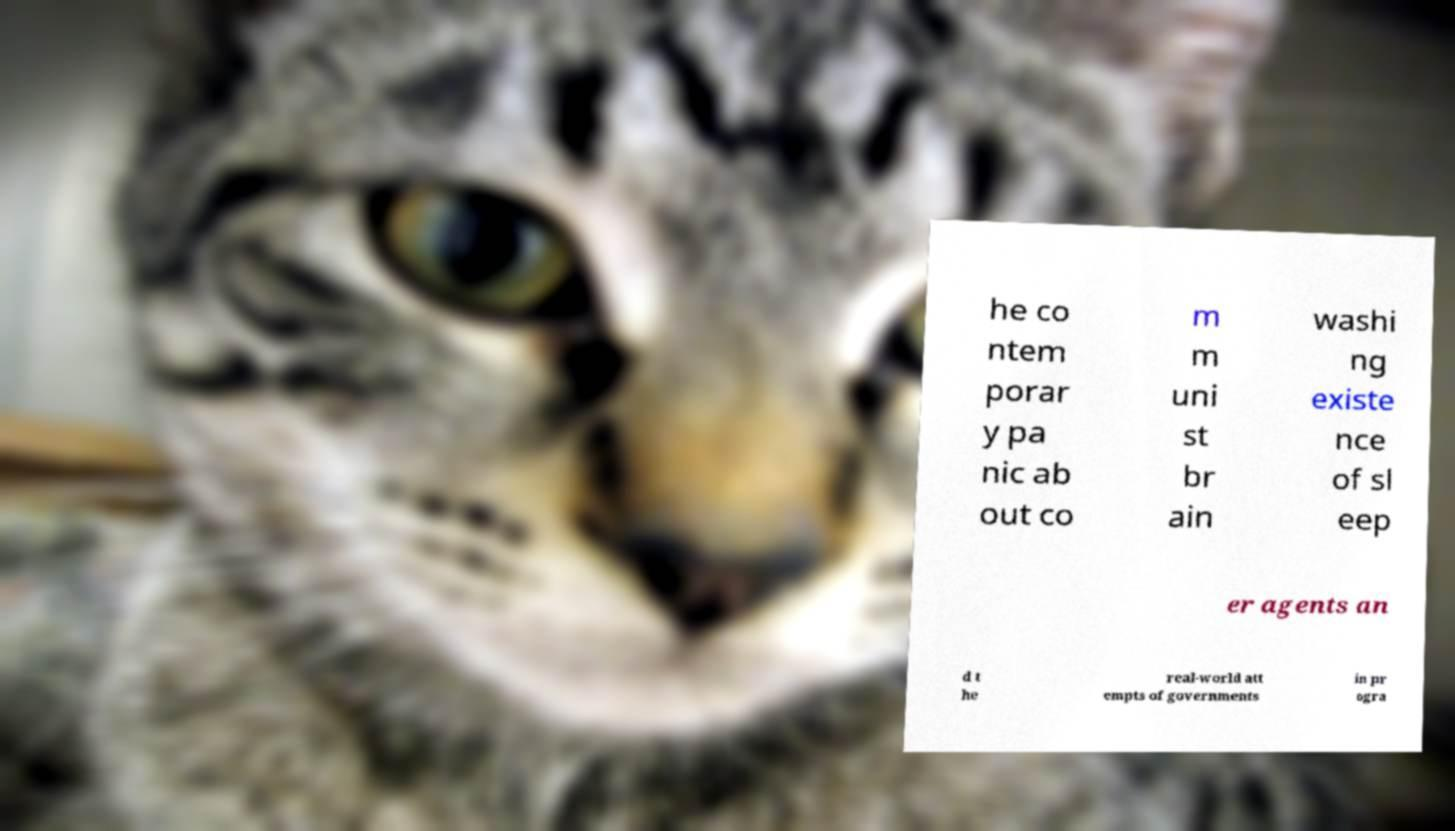Please identify and transcribe the text found in this image. he co ntem porar y pa nic ab out co m m uni st br ain washi ng existe nce of sl eep er agents an d t he real-world att empts of governments in pr ogra 